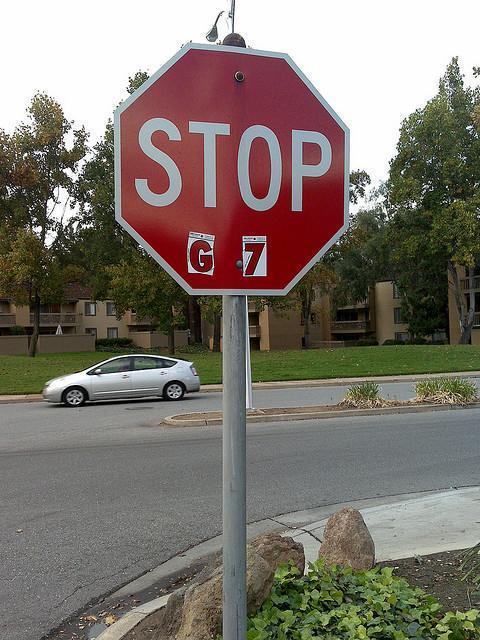How many cars are in the picture?
Give a very brief answer. 1. How many signs are there?
Give a very brief answer. 1. How many cars are shown?
Give a very brief answer. 1. How many cars can be seen?
Give a very brief answer. 1. How many signs are near the road?
Give a very brief answer. 1. How many birds are going to fly there in the image?
Give a very brief answer. 0. 